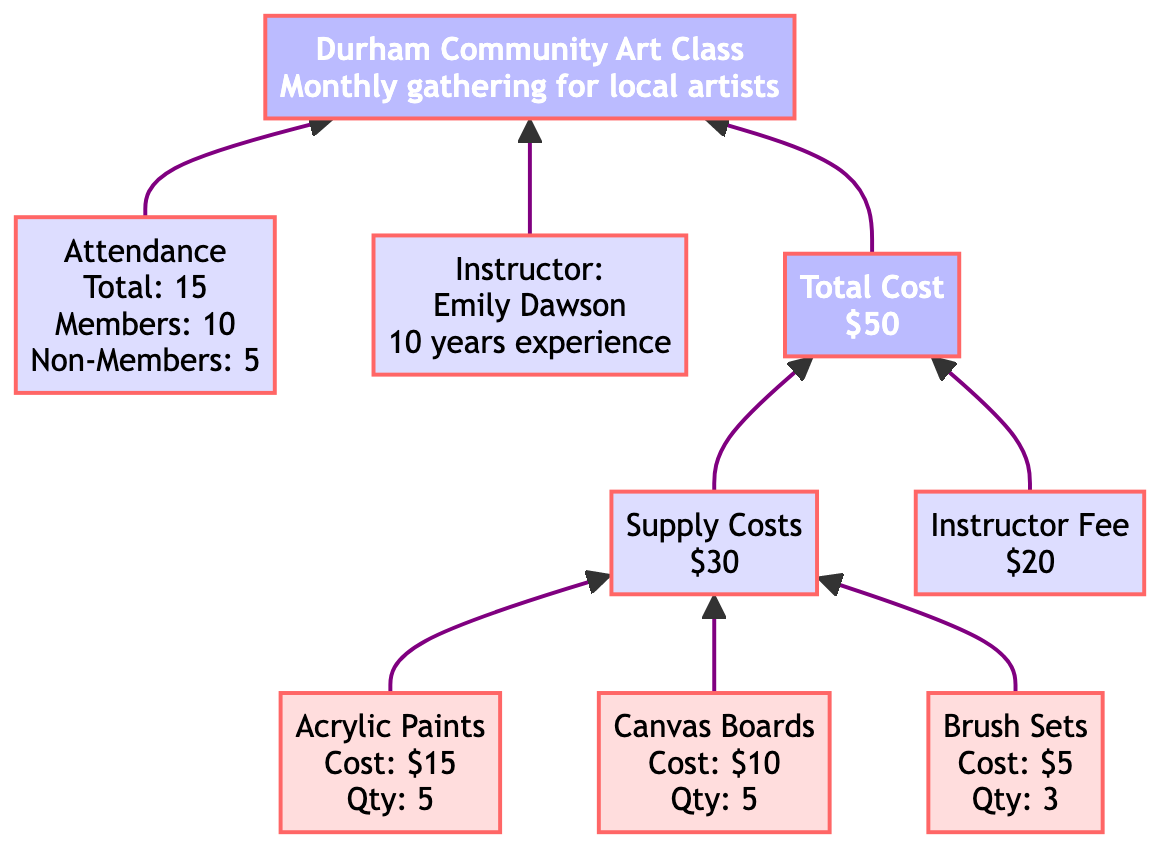What is the total cost of the art class? The "Total Cost" node shows the value "$50", indicating the overall expenditure for the class.
Answer: $50 Who is the instructor of the art class? In the "Instructor" node, the name "Emily Dawson" is provided, identifying her as the instructor for the art class.
Answer: Emily Dawson How many supplies are listed in the diagram? There are three supply items shown: "Acrylic Paints", "Canvas Boards", and "Brush Sets". Therefore, the total is three.
Answer: 3 What is the total number of participants? In the "Attendance" node, it states "Total: 15", indicating the total number of participants attending the class.
Answer: 15 How much does the supply cost contribute to the total cost? The "Supply Costs" node indicates that it contributes $30, which is part of the overall total cost of $50.
Answer: $30 What percentage of participants are non-members? The diagram states there are 5 non-members and a total of 15 participants. Therefore, the percentage is (5/15)*100 = 33.33%.
Answer: 33.33% How much do the acrylic paints cost? The "Acrylic Paints" node indicates its cost as "$15", which reveals the expense for that specific item.
Answer: $15 What is the relationship between supply costs and total cost? "Supply Costs" ($30) and "Instructor Fee" ($20) combine to form the "Total Cost" ($50), demonstrating how individual costs contribute to the overall expense.
Answer: Supply costs + Instructor fee = Total cost What does the instructor's experience indicate about her qualifications? The "Instructor" node states that Emily Dawson has "10 years of teaching art", signifying her established expertise in the field.
Answer: 10 years of teaching art 